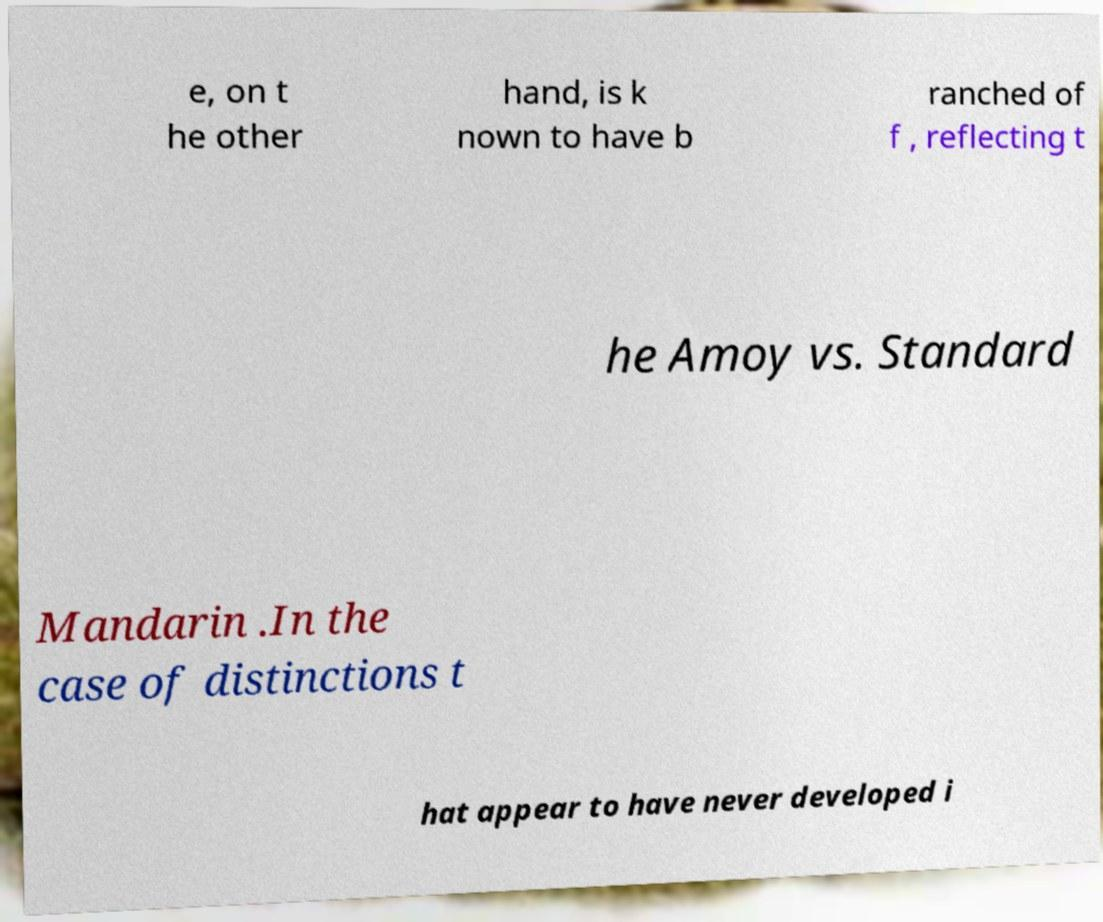What messages or text are displayed in this image? I need them in a readable, typed format. e, on t he other hand, is k nown to have b ranched of f , reflecting t he Amoy vs. Standard Mandarin .In the case of distinctions t hat appear to have never developed i 